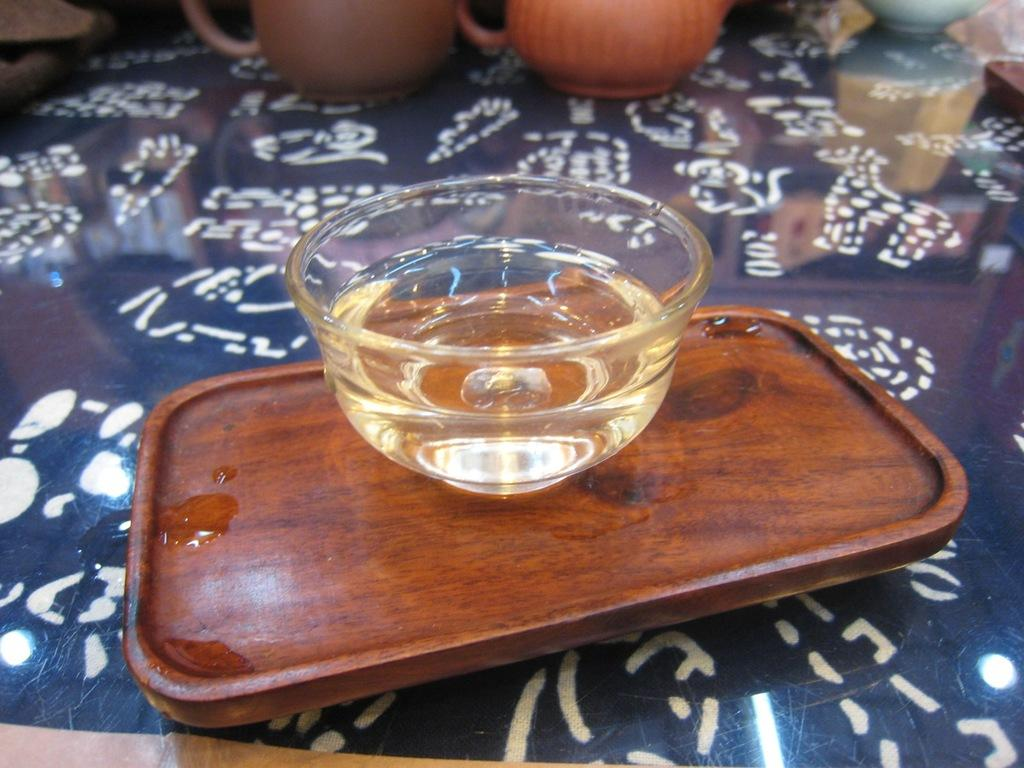What is in the glass cup that is visible in the image? There is an oil in a glass cup in the image. What is the glass cup placed on? The glass cup is on a wooden plate. Where is the wooden plate located? The wooden plate is on a table. How many cups are on the table? There are two cups on the table. What else can be seen on the table besides the cups? There are other objects on the table. How many girls are present in the image? There is no mention of girls in the provided facts, so we cannot determine the number of girls in the image. 